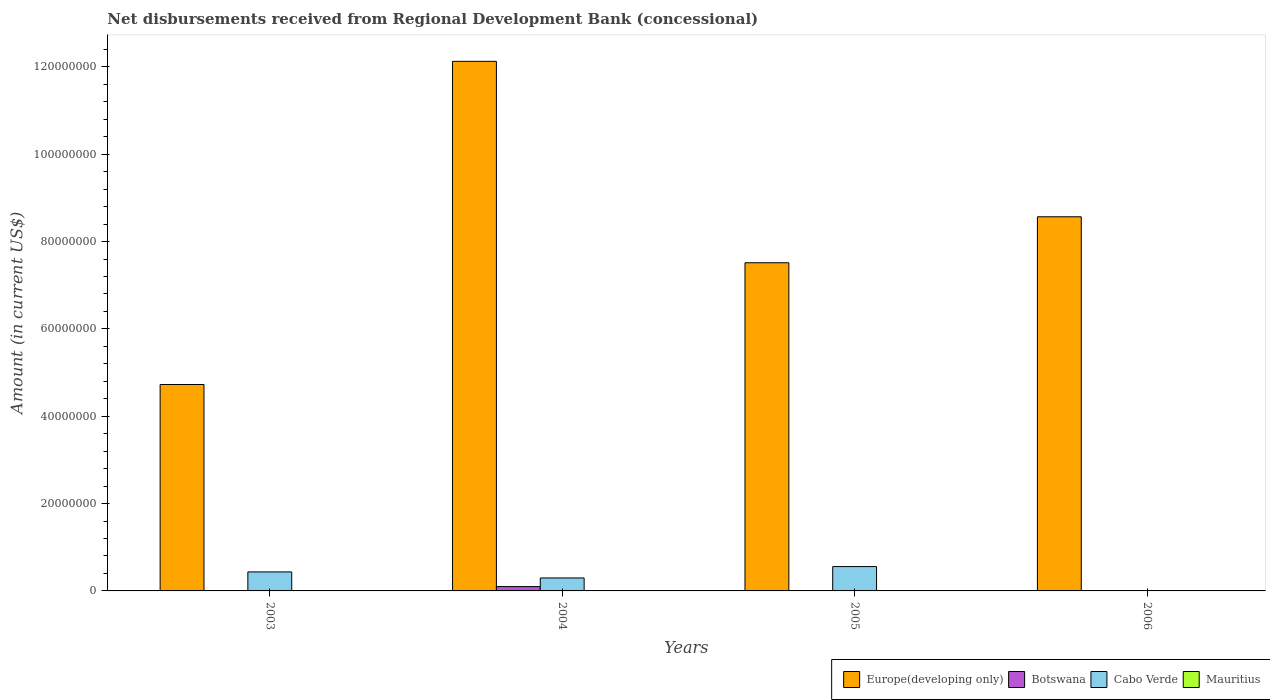Are the number of bars on each tick of the X-axis equal?
Make the answer very short. No. How many bars are there on the 1st tick from the left?
Your answer should be compact. 2. How many bars are there on the 1st tick from the right?
Your response must be concise. 1. What is the label of the 2nd group of bars from the left?
Your response must be concise. 2004. In how many cases, is the number of bars for a given year not equal to the number of legend labels?
Keep it short and to the point. 4. What is the amount of disbursements received from Regional Development Bank in Botswana in 2004?
Keep it short and to the point. 9.91e+05. Across all years, what is the maximum amount of disbursements received from Regional Development Bank in Europe(developing only)?
Give a very brief answer. 1.21e+08. Across all years, what is the minimum amount of disbursements received from Regional Development Bank in Europe(developing only)?
Offer a very short reply. 4.73e+07. In which year was the amount of disbursements received from Regional Development Bank in Botswana maximum?
Your response must be concise. 2004. What is the total amount of disbursements received from Regional Development Bank in Europe(developing only) in the graph?
Provide a short and direct response. 3.29e+08. What is the difference between the amount of disbursements received from Regional Development Bank in Europe(developing only) in 2003 and that in 2004?
Provide a succinct answer. -7.40e+07. What is the difference between the amount of disbursements received from Regional Development Bank in Botswana in 2006 and the amount of disbursements received from Regional Development Bank in Cabo Verde in 2004?
Your answer should be compact. -2.97e+06. In the year 2004, what is the difference between the amount of disbursements received from Regional Development Bank in Botswana and amount of disbursements received from Regional Development Bank in Europe(developing only)?
Make the answer very short. -1.20e+08. What is the ratio of the amount of disbursements received from Regional Development Bank in Europe(developing only) in 2003 to that in 2005?
Provide a short and direct response. 0.63. Is the amount of disbursements received from Regional Development Bank in Cabo Verde in 2003 less than that in 2004?
Your response must be concise. No. What is the difference between the highest and the second highest amount of disbursements received from Regional Development Bank in Cabo Verde?
Keep it short and to the point. 1.22e+06. What is the difference between the highest and the lowest amount of disbursements received from Regional Development Bank in Cabo Verde?
Offer a terse response. 5.58e+06. In how many years, is the amount of disbursements received from Regional Development Bank in Mauritius greater than the average amount of disbursements received from Regional Development Bank in Mauritius taken over all years?
Ensure brevity in your answer.  0. Is the sum of the amount of disbursements received from Regional Development Bank in Europe(developing only) in 2005 and 2006 greater than the maximum amount of disbursements received from Regional Development Bank in Botswana across all years?
Provide a short and direct response. Yes. How many bars are there?
Your answer should be very brief. 8. What is the difference between two consecutive major ticks on the Y-axis?
Offer a very short reply. 2.00e+07. Does the graph contain any zero values?
Provide a succinct answer. Yes. Does the graph contain grids?
Provide a short and direct response. No. What is the title of the graph?
Your answer should be very brief. Net disbursements received from Regional Development Bank (concessional). What is the label or title of the X-axis?
Your answer should be very brief. Years. What is the label or title of the Y-axis?
Your answer should be compact. Amount (in current US$). What is the Amount (in current US$) in Europe(developing only) in 2003?
Give a very brief answer. 4.73e+07. What is the Amount (in current US$) in Cabo Verde in 2003?
Your answer should be compact. 4.35e+06. What is the Amount (in current US$) of Mauritius in 2003?
Keep it short and to the point. 0. What is the Amount (in current US$) of Europe(developing only) in 2004?
Offer a terse response. 1.21e+08. What is the Amount (in current US$) in Botswana in 2004?
Offer a very short reply. 9.91e+05. What is the Amount (in current US$) in Cabo Verde in 2004?
Your response must be concise. 2.97e+06. What is the Amount (in current US$) of Mauritius in 2004?
Provide a succinct answer. 0. What is the Amount (in current US$) in Europe(developing only) in 2005?
Offer a very short reply. 7.52e+07. What is the Amount (in current US$) in Cabo Verde in 2005?
Your answer should be compact. 5.58e+06. What is the Amount (in current US$) of Mauritius in 2005?
Your response must be concise. 0. What is the Amount (in current US$) in Europe(developing only) in 2006?
Your answer should be very brief. 8.57e+07. What is the Amount (in current US$) in Botswana in 2006?
Your answer should be compact. 0. What is the Amount (in current US$) in Cabo Verde in 2006?
Ensure brevity in your answer.  0. What is the Amount (in current US$) in Mauritius in 2006?
Your response must be concise. 0. Across all years, what is the maximum Amount (in current US$) in Europe(developing only)?
Offer a very short reply. 1.21e+08. Across all years, what is the maximum Amount (in current US$) of Botswana?
Your answer should be very brief. 9.91e+05. Across all years, what is the maximum Amount (in current US$) of Cabo Verde?
Make the answer very short. 5.58e+06. Across all years, what is the minimum Amount (in current US$) in Europe(developing only)?
Provide a succinct answer. 4.73e+07. What is the total Amount (in current US$) in Europe(developing only) in the graph?
Your response must be concise. 3.29e+08. What is the total Amount (in current US$) of Botswana in the graph?
Give a very brief answer. 9.91e+05. What is the total Amount (in current US$) of Cabo Verde in the graph?
Give a very brief answer. 1.29e+07. What is the difference between the Amount (in current US$) of Europe(developing only) in 2003 and that in 2004?
Provide a short and direct response. -7.40e+07. What is the difference between the Amount (in current US$) in Cabo Verde in 2003 and that in 2004?
Your response must be concise. 1.38e+06. What is the difference between the Amount (in current US$) in Europe(developing only) in 2003 and that in 2005?
Your answer should be compact. -2.79e+07. What is the difference between the Amount (in current US$) in Cabo Verde in 2003 and that in 2005?
Make the answer very short. -1.22e+06. What is the difference between the Amount (in current US$) of Europe(developing only) in 2003 and that in 2006?
Give a very brief answer. -3.84e+07. What is the difference between the Amount (in current US$) in Europe(developing only) in 2004 and that in 2005?
Offer a very short reply. 4.61e+07. What is the difference between the Amount (in current US$) of Cabo Verde in 2004 and that in 2005?
Give a very brief answer. -2.61e+06. What is the difference between the Amount (in current US$) of Europe(developing only) in 2004 and that in 2006?
Provide a succinct answer. 3.56e+07. What is the difference between the Amount (in current US$) in Europe(developing only) in 2005 and that in 2006?
Ensure brevity in your answer.  -1.05e+07. What is the difference between the Amount (in current US$) of Europe(developing only) in 2003 and the Amount (in current US$) of Botswana in 2004?
Make the answer very short. 4.63e+07. What is the difference between the Amount (in current US$) of Europe(developing only) in 2003 and the Amount (in current US$) of Cabo Verde in 2004?
Make the answer very short. 4.43e+07. What is the difference between the Amount (in current US$) of Europe(developing only) in 2003 and the Amount (in current US$) of Cabo Verde in 2005?
Your response must be concise. 4.17e+07. What is the difference between the Amount (in current US$) in Europe(developing only) in 2004 and the Amount (in current US$) in Cabo Verde in 2005?
Provide a short and direct response. 1.16e+08. What is the difference between the Amount (in current US$) of Botswana in 2004 and the Amount (in current US$) of Cabo Verde in 2005?
Your answer should be very brief. -4.58e+06. What is the average Amount (in current US$) of Europe(developing only) per year?
Provide a short and direct response. 8.23e+07. What is the average Amount (in current US$) of Botswana per year?
Offer a terse response. 2.48e+05. What is the average Amount (in current US$) of Cabo Verde per year?
Provide a succinct answer. 3.22e+06. What is the average Amount (in current US$) in Mauritius per year?
Keep it short and to the point. 0. In the year 2003, what is the difference between the Amount (in current US$) in Europe(developing only) and Amount (in current US$) in Cabo Verde?
Your answer should be very brief. 4.29e+07. In the year 2004, what is the difference between the Amount (in current US$) of Europe(developing only) and Amount (in current US$) of Botswana?
Offer a terse response. 1.20e+08. In the year 2004, what is the difference between the Amount (in current US$) of Europe(developing only) and Amount (in current US$) of Cabo Verde?
Your response must be concise. 1.18e+08. In the year 2004, what is the difference between the Amount (in current US$) of Botswana and Amount (in current US$) of Cabo Verde?
Provide a short and direct response. -1.98e+06. In the year 2005, what is the difference between the Amount (in current US$) of Europe(developing only) and Amount (in current US$) of Cabo Verde?
Ensure brevity in your answer.  6.96e+07. What is the ratio of the Amount (in current US$) in Europe(developing only) in 2003 to that in 2004?
Give a very brief answer. 0.39. What is the ratio of the Amount (in current US$) in Cabo Verde in 2003 to that in 2004?
Make the answer very short. 1.47. What is the ratio of the Amount (in current US$) in Europe(developing only) in 2003 to that in 2005?
Your answer should be compact. 0.63. What is the ratio of the Amount (in current US$) in Cabo Verde in 2003 to that in 2005?
Provide a short and direct response. 0.78. What is the ratio of the Amount (in current US$) of Europe(developing only) in 2003 to that in 2006?
Your answer should be very brief. 0.55. What is the ratio of the Amount (in current US$) in Europe(developing only) in 2004 to that in 2005?
Keep it short and to the point. 1.61. What is the ratio of the Amount (in current US$) of Cabo Verde in 2004 to that in 2005?
Ensure brevity in your answer.  0.53. What is the ratio of the Amount (in current US$) in Europe(developing only) in 2004 to that in 2006?
Offer a terse response. 1.42. What is the ratio of the Amount (in current US$) in Europe(developing only) in 2005 to that in 2006?
Keep it short and to the point. 0.88. What is the difference between the highest and the second highest Amount (in current US$) in Europe(developing only)?
Your response must be concise. 3.56e+07. What is the difference between the highest and the second highest Amount (in current US$) of Cabo Verde?
Make the answer very short. 1.22e+06. What is the difference between the highest and the lowest Amount (in current US$) in Europe(developing only)?
Your answer should be very brief. 7.40e+07. What is the difference between the highest and the lowest Amount (in current US$) of Botswana?
Give a very brief answer. 9.91e+05. What is the difference between the highest and the lowest Amount (in current US$) of Cabo Verde?
Provide a succinct answer. 5.58e+06. 